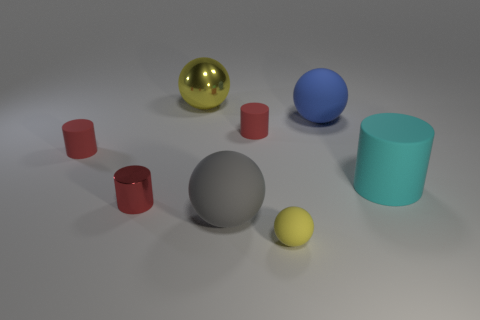There is a gray matte thing that is the same shape as the large yellow shiny object; what is its size?
Your answer should be very brief. Large. What is the big yellow object made of?
Keep it short and to the point. Metal. There is a yellow thing behind the red cylinder that is on the right side of the large ball that is in front of the cyan object; what is it made of?
Your answer should be compact. Metal. There is a metallic thing behind the blue matte ball; is its size the same as the rubber sphere that is behind the big gray ball?
Your answer should be compact. Yes. How many other things are made of the same material as the big yellow object?
Ensure brevity in your answer.  1. What number of metallic things are either big cyan things or tiny cylinders?
Make the answer very short. 1. Are there fewer big gray rubber things than gray shiny spheres?
Ensure brevity in your answer.  No. Does the metallic ball have the same size as the cyan cylinder behind the metal cylinder?
Provide a succinct answer. Yes. The metal cylinder is what size?
Offer a very short reply. Small. Are there fewer yellow spheres left of the large cyan cylinder than yellow matte objects?
Offer a terse response. No. 